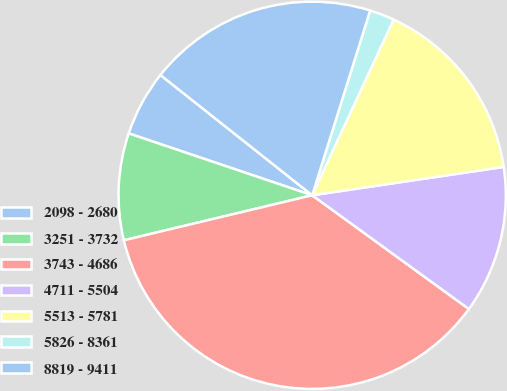<chart> <loc_0><loc_0><loc_500><loc_500><pie_chart><fcel>2098 - 2680<fcel>3251 - 3732<fcel>3743 - 4686<fcel>4711 - 5504<fcel>5513 - 5781<fcel>5826 - 8361<fcel>8819 - 9411<nl><fcel>5.49%<fcel>8.91%<fcel>36.27%<fcel>12.33%<fcel>15.75%<fcel>2.07%<fcel>19.17%<nl></chart> 